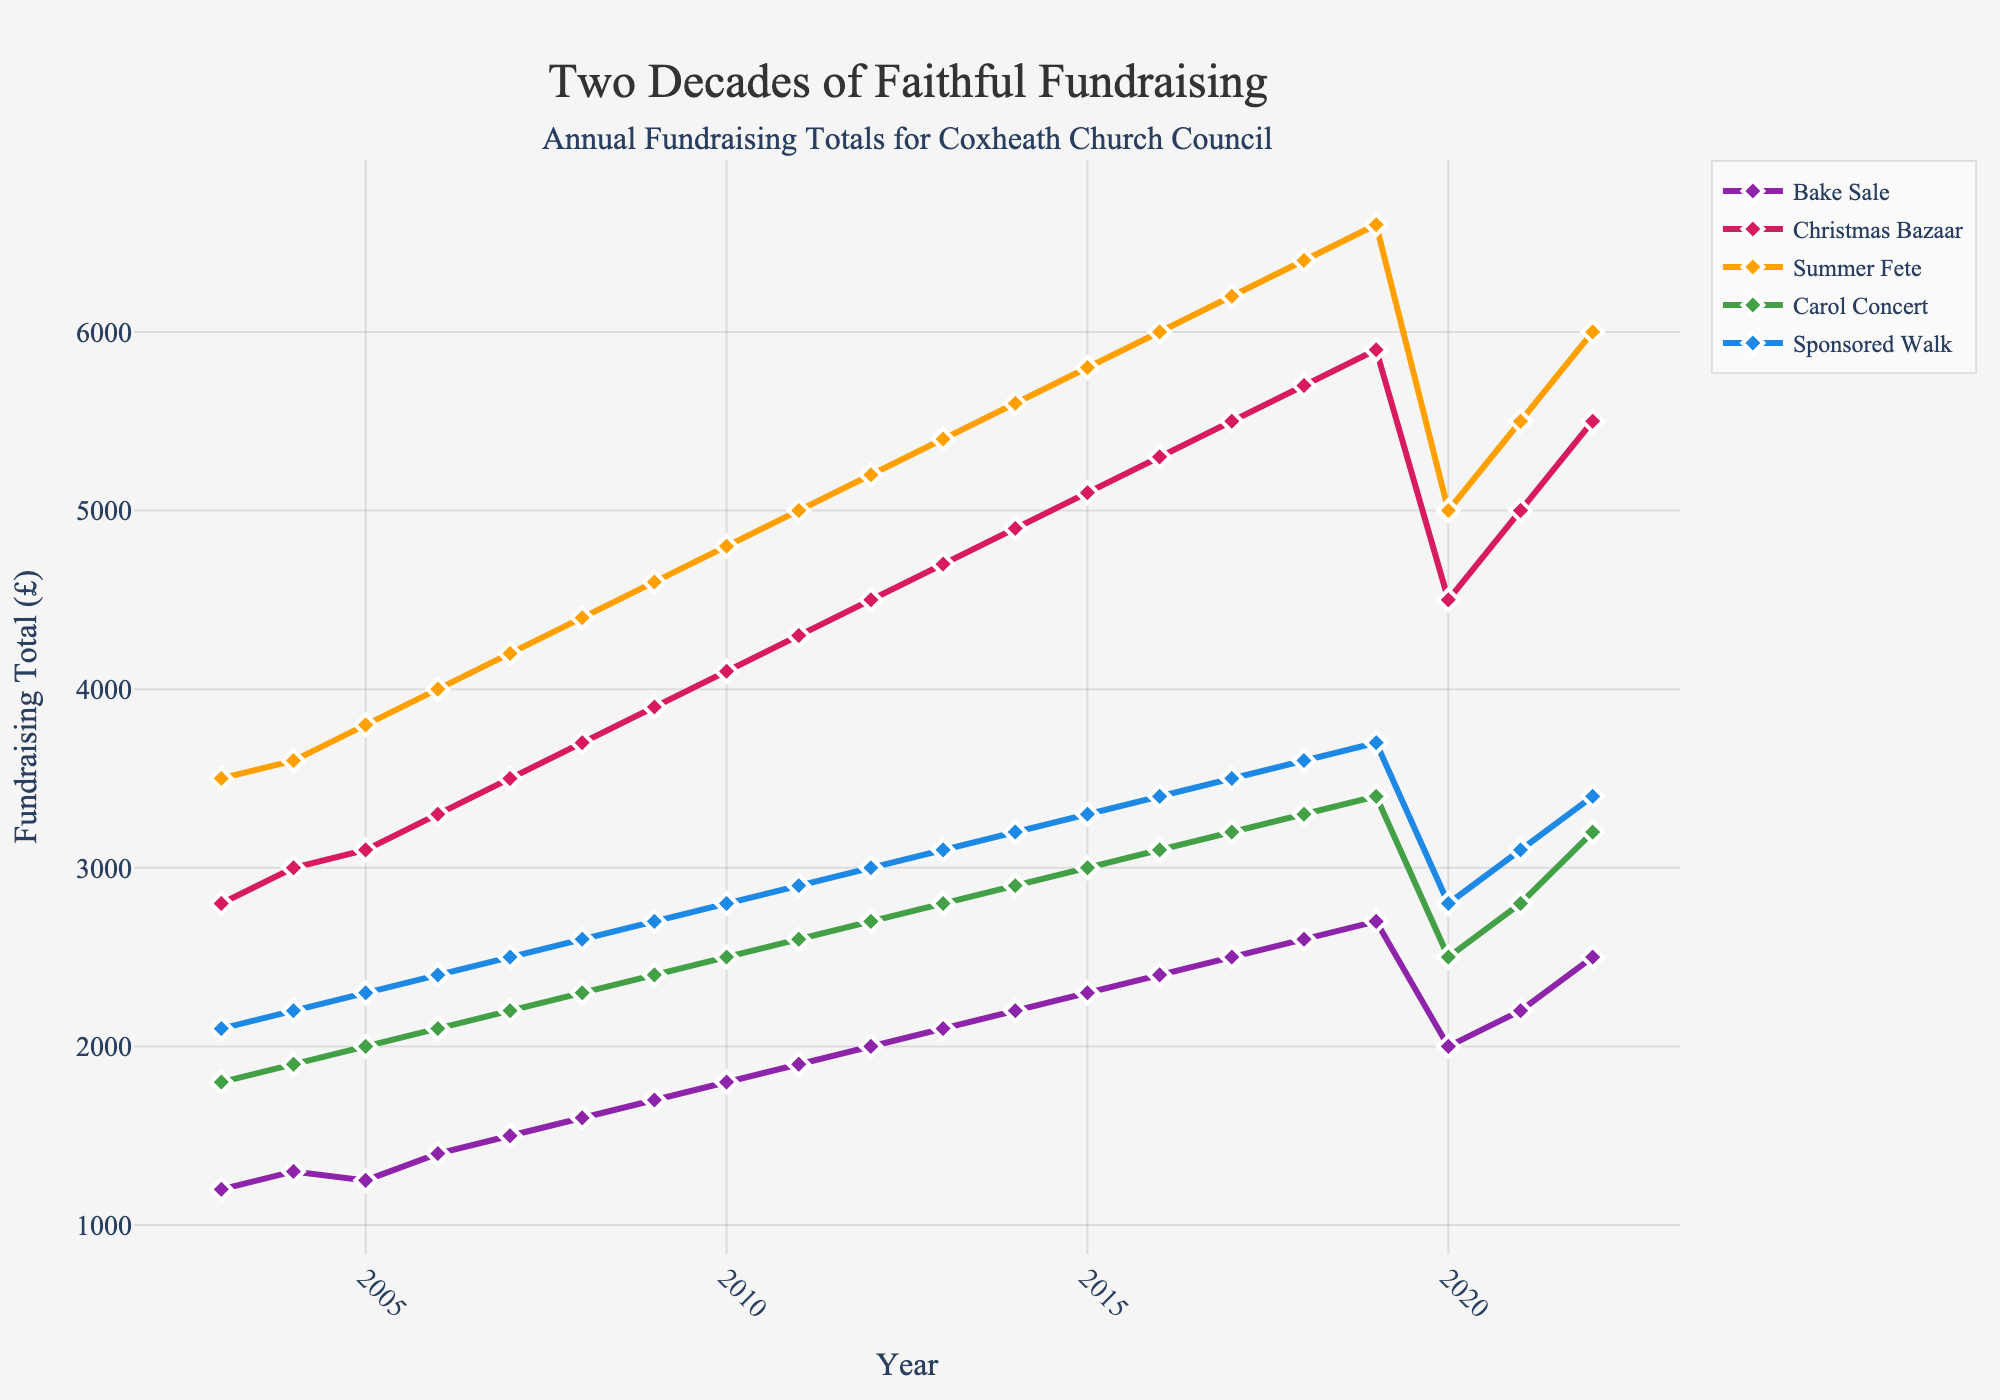When did the Sponsored Walk fundraising total first surpass £3000? We look at the Sponsored Walk plot and track the years right above the £3000 mark. It happened in 2012.
Answer: 2012 By how much did the Christmas Bazaar fundraising total drop from its peak in 2019 to the lowest point in 2020? The Christmas Bazaar total peak in 2019 was £5900. In 2020, it dropped to £4500. The decrease is £5900 - £4500.
Answer: £1400 Which event consistently raised the most funds over the 20 years? By observing the height of the lines for all events, the Summer Fete has the highest totals consistently.
Answer: Summer Fete What’s the average fundraising total for the Bake Sale from 2018 to 2022? The totals for the Bake Sale from 2018 to 2022 are £2600, £2700, £2000, £2200, and £2500. The average is calculated as (2600+2700+2000+2200+2500)/5.
Answer: £2400 Compare the totals for the Summer Fete and Carol Concert in 2022. Which one raised more and by how much? The total for Summer Fete in 2022 is £6000 and for the Carol Concert is £3200. The difference is £6000 - £3200.
Answer: Summer Fete by £2800 Which event experienced the largest drop in fundraising total from 2019 to 2020? By comparing the decreases in the lines from 2019 to 2020 for all events, the Summer Fete had the largest drop from £6600 to £5000, a difference of £1600.
Answer: Summer Fete How did the fundraising total for the Carol Concert change from 2005 to 2007? The Carol Concert total in 2005 was £2000, and in 2007 it was £2200. The change is £2200 - £2000.
Answer: Increased by £200 What is the difference between the highest and lowest fundraising totals for the Summer Fete over the 20 years? The highest total for the Summer Fete is £6600 in 2019, and the lowest is £3500 in 2003. The difference is £6600 - £3500.
Answer: £3100 What was the general trend of the Christmas Bazaar fund from 2003 to 2019? The line for the Christmas Bazaar from 2003 to 2019 generally trends upwards.
Answer: Upward trend By how much did the Bake Sale fundraising total increase from 2011 to 2016? The Bake Sale total in 2011 was £1900, and in 2016 it was £2400. The increase is £2400 - £1900.
Answer: £500 